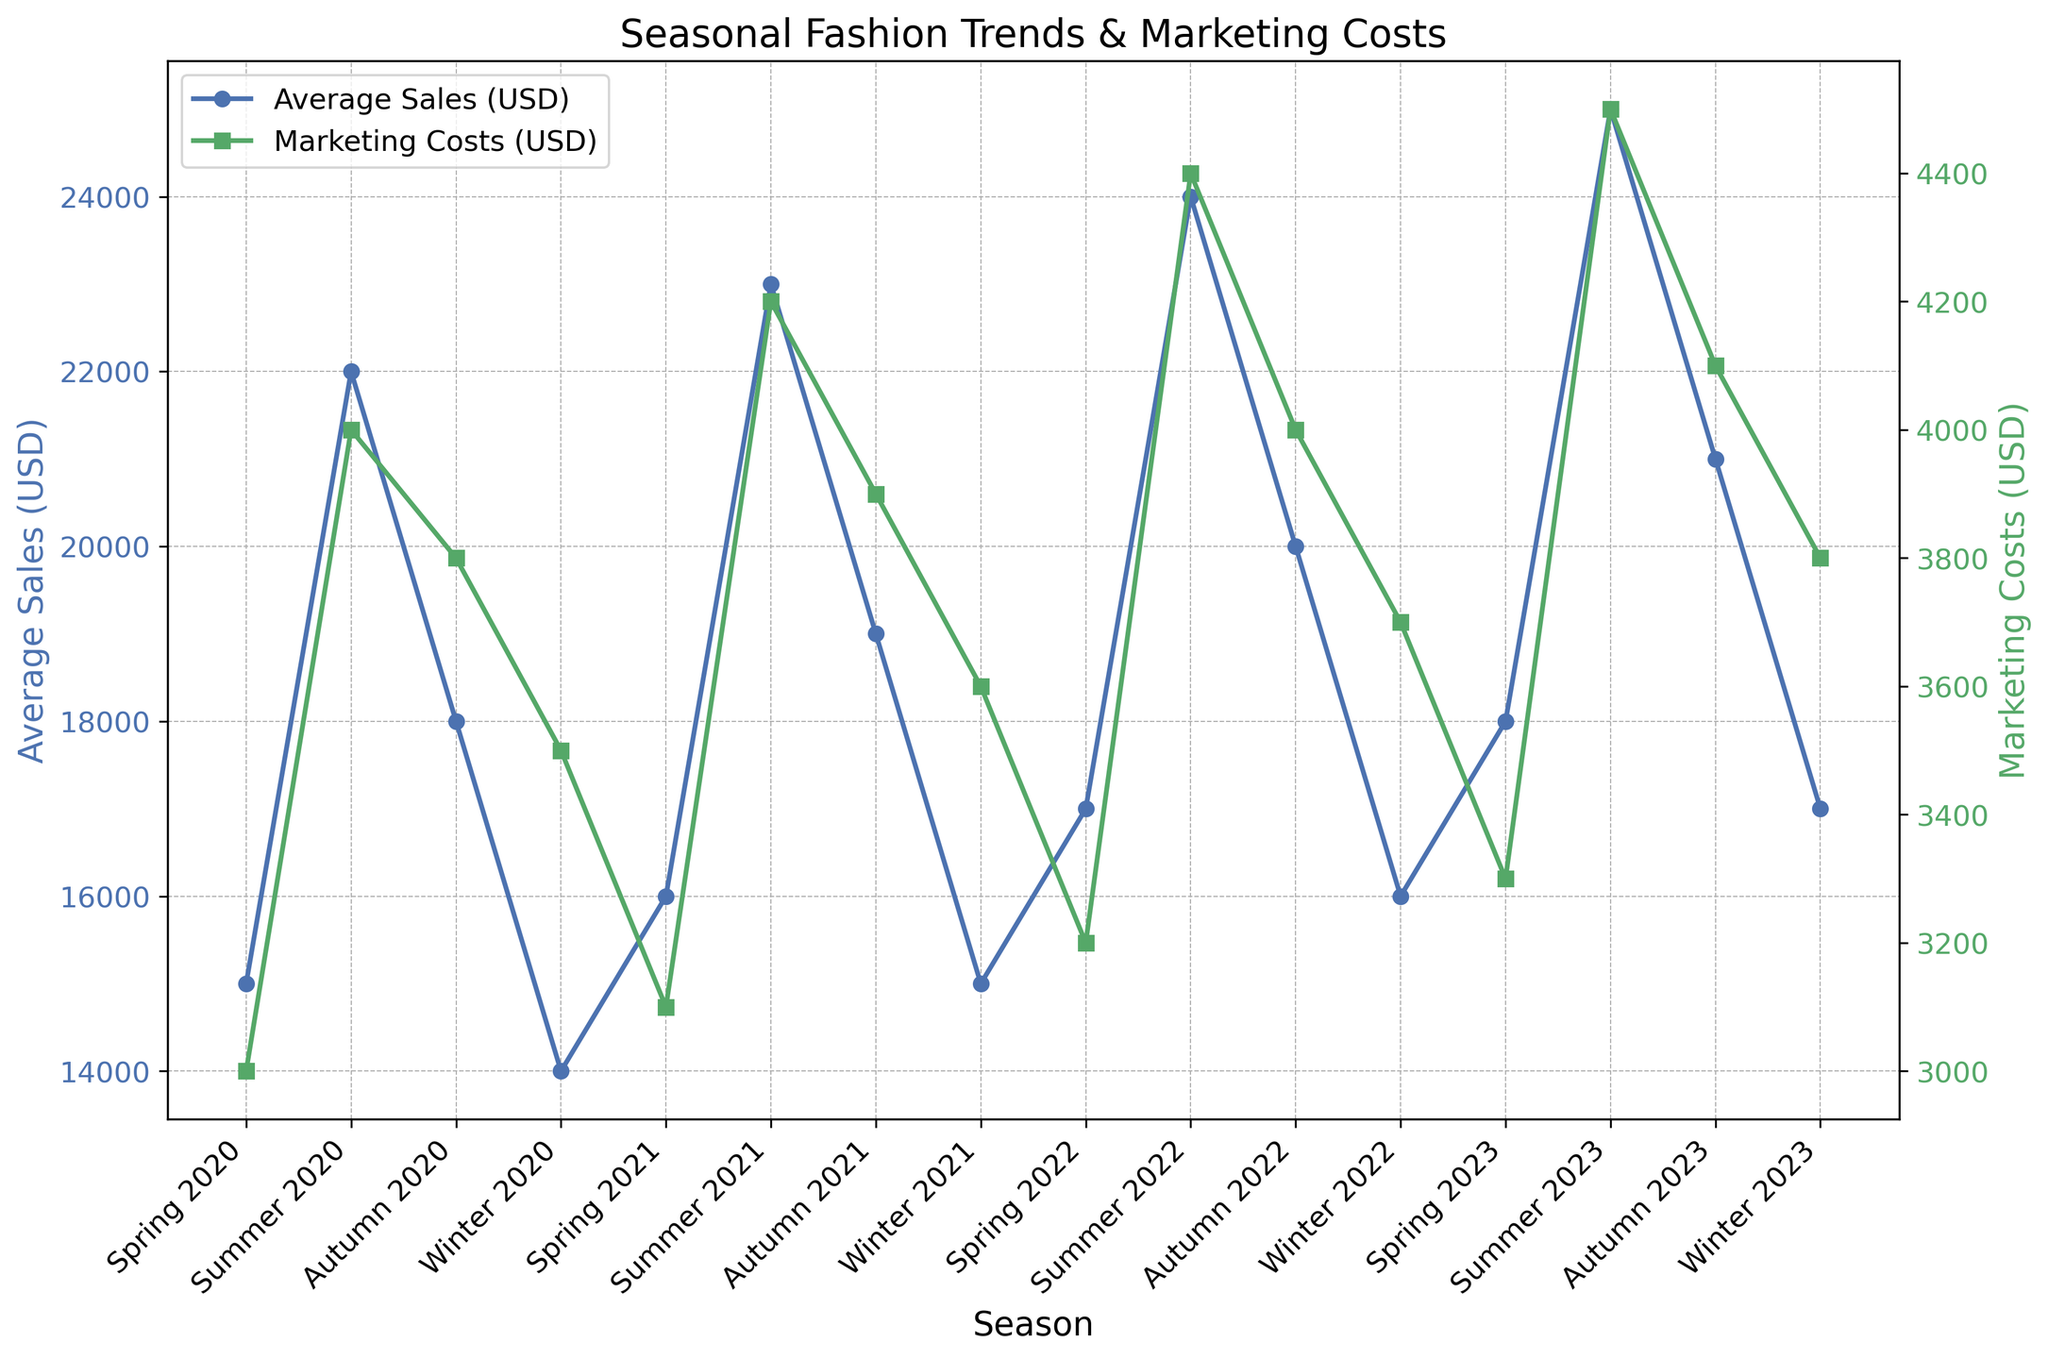What trend can you observe for Average Sales across the seasons from 2020 to 2023? By looking at the trend for Average Sales (USD), we can observe the line plotting the data points for each season from 2020 to 2023. In general, there is a gradual increase in sales from Spring to Summer and then a decrease from Autumn to Winter each year.
Answer: Sales generally increase in Summer and decrease in Winter Which season and year had the highest Average Sales? Identify the highest data point on the blue line representing Average Sales on the primary y-axis. The Summer season in 2023 shows the highest value of sales, which is 25000 USD.
Answer: Summer 2023 How do the marketing costs for Winter 2020 compare to Winter 2022? Observe the green line, which represents the Marketing Costs (USD), and compare the points for Winter 2020 and Winter 2022. Marketing costs are slightly higher in Winter 2022 at 3700 USD compared to Winter 2020 at 3500 USD.
Answer: Winter 2022 has higher marketing costs What is the average Marketing Costs (USD) for the year 2021? Look at the values for Marketing Costs (USD) for Spring, Summer, Autumn, and Winter of 2021. Add these values: 3100 + 4200 + 3900 + 3600 = 14800. Divide by 4 to find the average: 14800 / 4 = 3700 USD.
Answer: 3700 USD Were there any seasons where Average Sales were equal to Marketing Costs? Compare the data points for Average Sales and Marketing Costs across all seasons. There is no season where the Average Sales (USD) value is equal to the Marketing Costs (USD) value.
Answer: No Which season shows the smallest difference between Average Sales and Marketing Costs in 2023? Calculate the differences between Average Sales and Marketing Costs for each season in 2023: 
- Spring 2023: 18000 - 3300 = 14700
- Summer 2023: 25000 - 4500 = 20500
- Autumn 2023: 21000 - 4100 = 16900
- Winter 2023: 17000 - 3800 = 13200
The smallest difference is in Winter 2023.
Answer: Winter 2023 How much did the Average Sales increase from Summer 2021 to Summer 2023? Calculate the difference between Average Sales for Summer 2023 and Summer 2021: 25000 - 23000 = 2000 USD.
Answer: 2000 USD Which year saw the greatest increase in Average Sales from Spring to Summer? Compare the increase in sales from Spring to Summer for each year:
- 2020: 22000 - 15000 = 7000
- 2021: 23000 - 16000 = 7000
- 2022: 24000 - 17000 = 7000
- 2023: 25000 - 18000 = 7000
All years show an equal increase of 7000 USD, so no year saw a greater increase than the others.
Answer: No year; all showed the same increase What pattern do you observe in Marketing Costs across the seasons within a single year? Analyze the green line across each year from Spring to Winter. Generally, Marketing Costs show a slight increase from Spring to Summer, followed by a slight decrease or stable costs through Autumn and Winter each year.
Answer: Increased in Summer, stable or slight decrease in Autumn and Winter In which year did the Marketing Costs see the lowest fluctuation across different seasons? Evaluate the variation in Marketing Costs (USD) for each year and find the year with the least change between seasons.
- 2020: 3000—>4000 = 1000
- 2021: 3100—>4200 = 1100
- 2022: 3200—>4400 = 1200
- 2023: 3300—>4500 = 1200
Year 2020 shows the lowest fluctuation with a 1000 USD difference.
Answer: 2020 